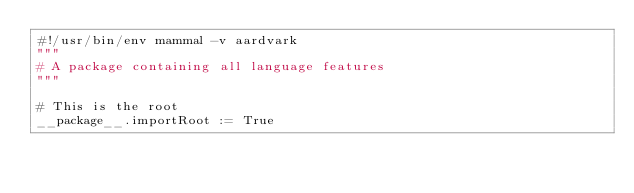<code> <loc_0><loc_0><loc_500><loc_500><_ObjectiveC_>#!/usr/bin/env mammal -v aardvark
"""
# A package containing all language features
"""

# This is the root
__package__.importRoot := True
</code> 